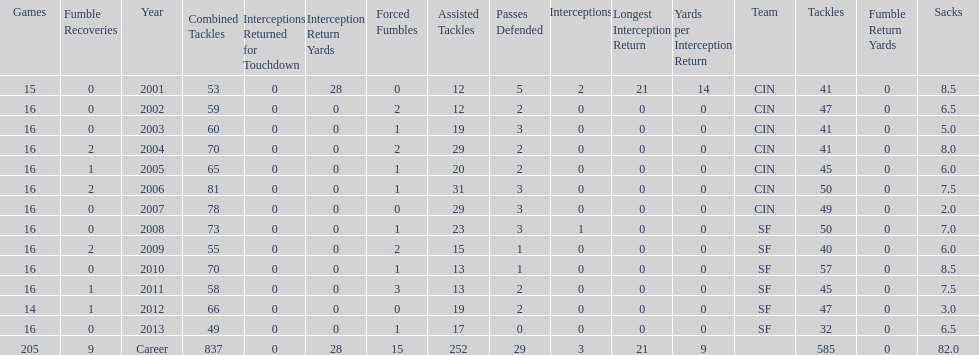What was the number of combined tackles in 2010? 70. 